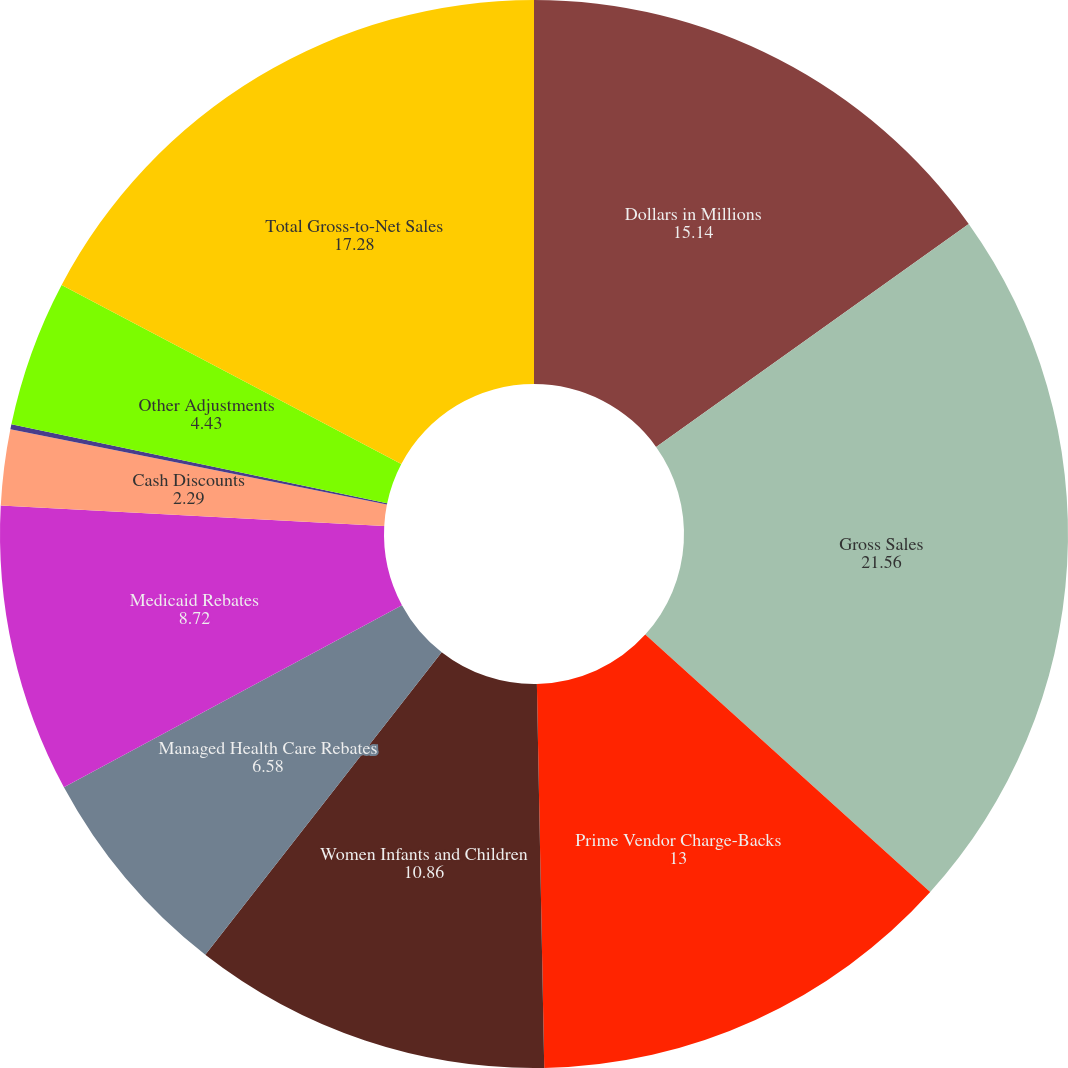Convert chart. <chart><loc_0><loc_0><loc_500><loc_500><pie_chart><fcel>Dollars in Millions<fcel>Gross Sales<fcel>Prime Vendor Charge-Backs<fcel>Women Infants and Children<fcel>Managed Health Care Rebates<fcel>Medicaid Rebates<fcel>Cash Discounts<fcel>Sales Returns<fcel>Other Adjustments<fcel>Total Gross-to-Net Sales<nl><fcel>15.14%<fcel>21.56%<fcel>13.0%<fcel>10.86%<fcel>6.58%<fcel>8.72%<fcel>2.29%<fcel>0.15%<fcel>4.43%<fcel>17.28%<nl></chart> 